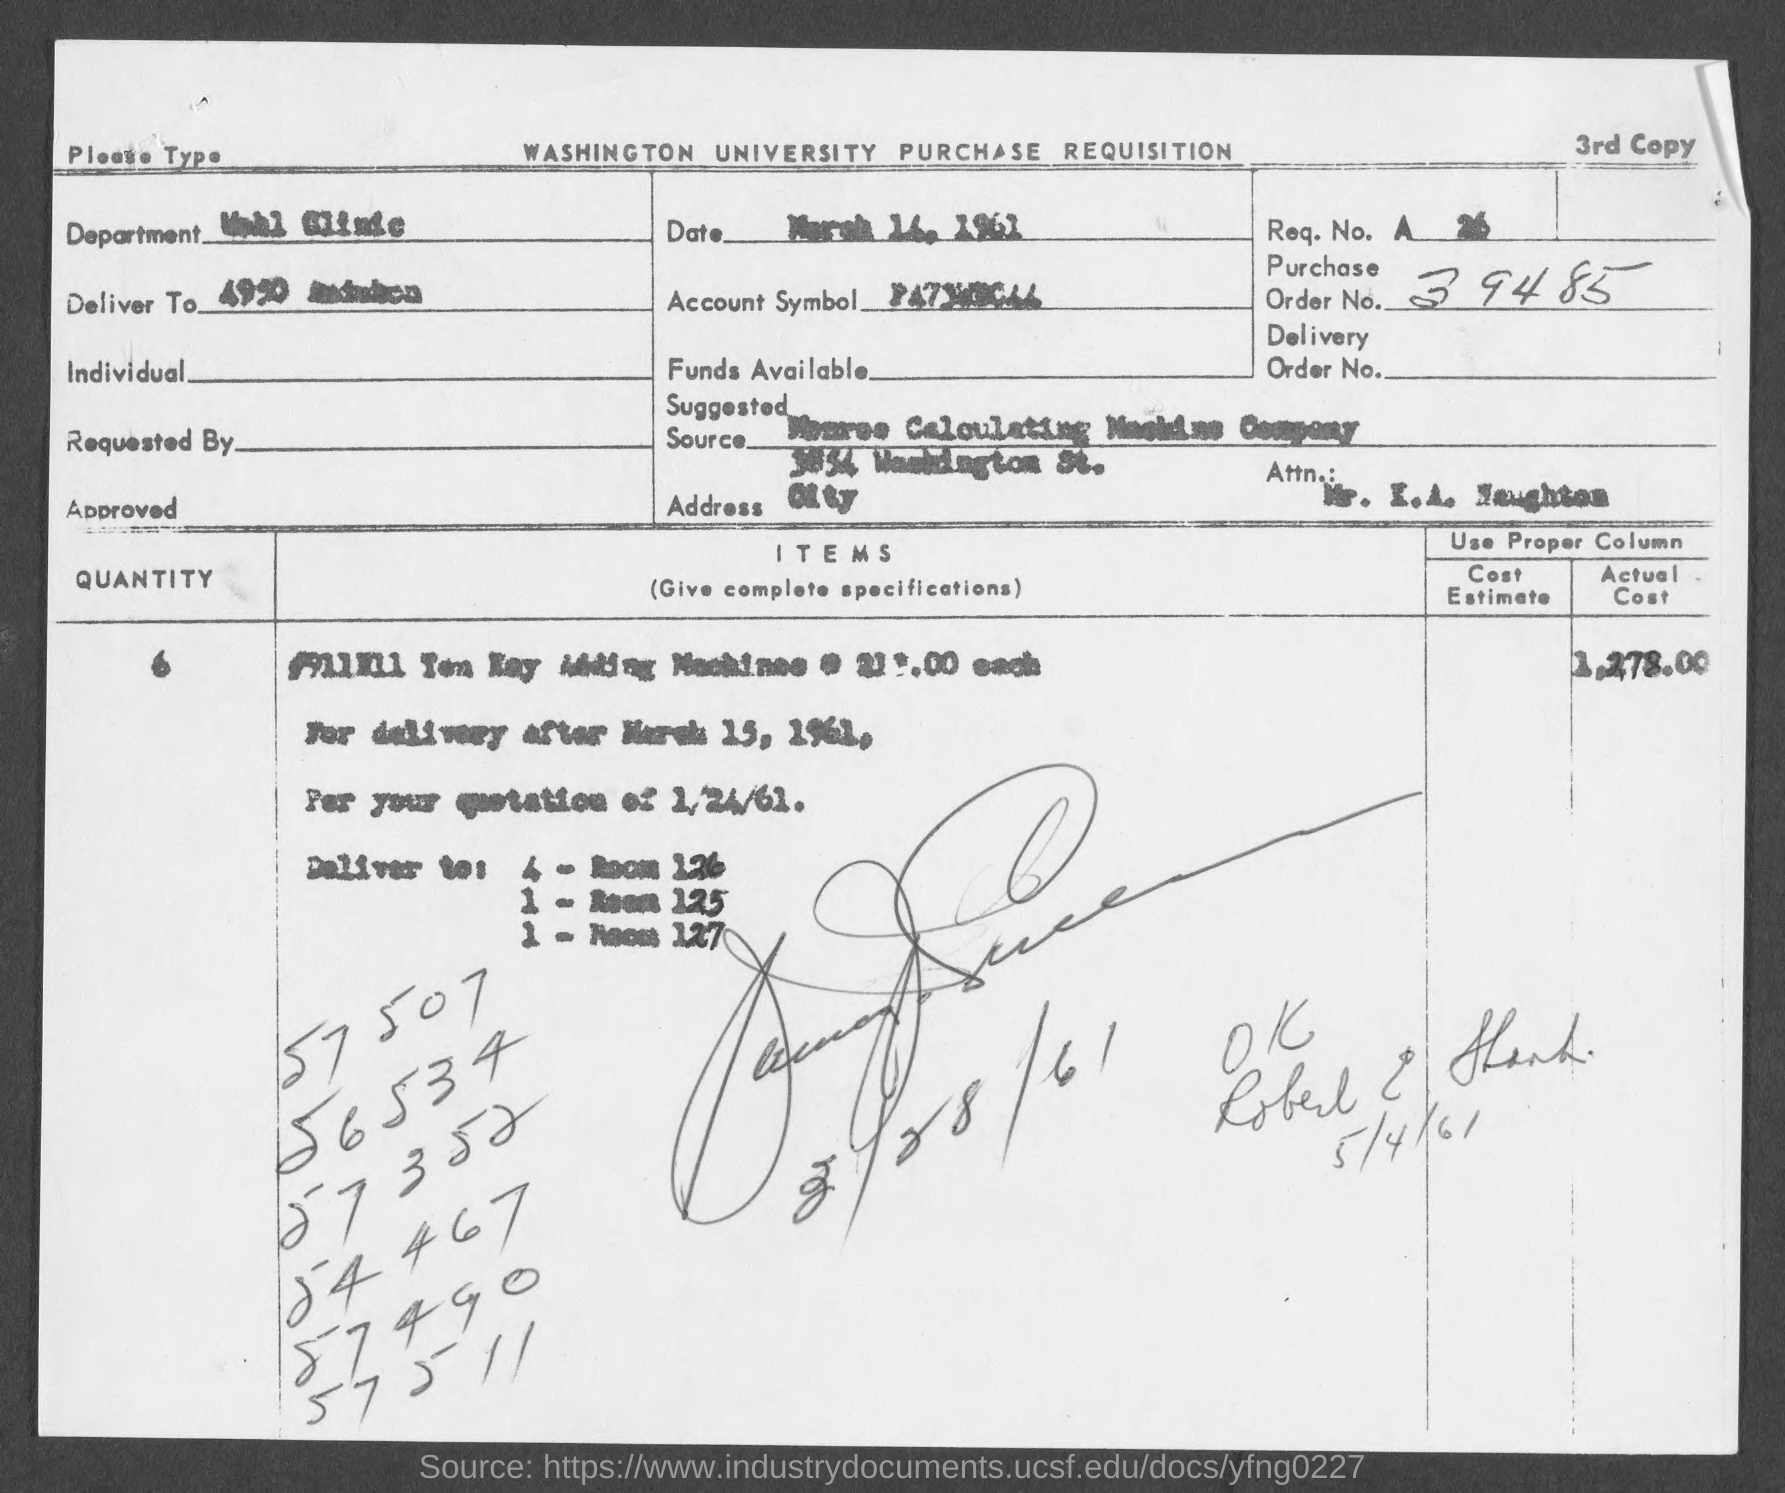Point out several critical features in this image. The sentence is "What is the purchase order number? 39485...". 